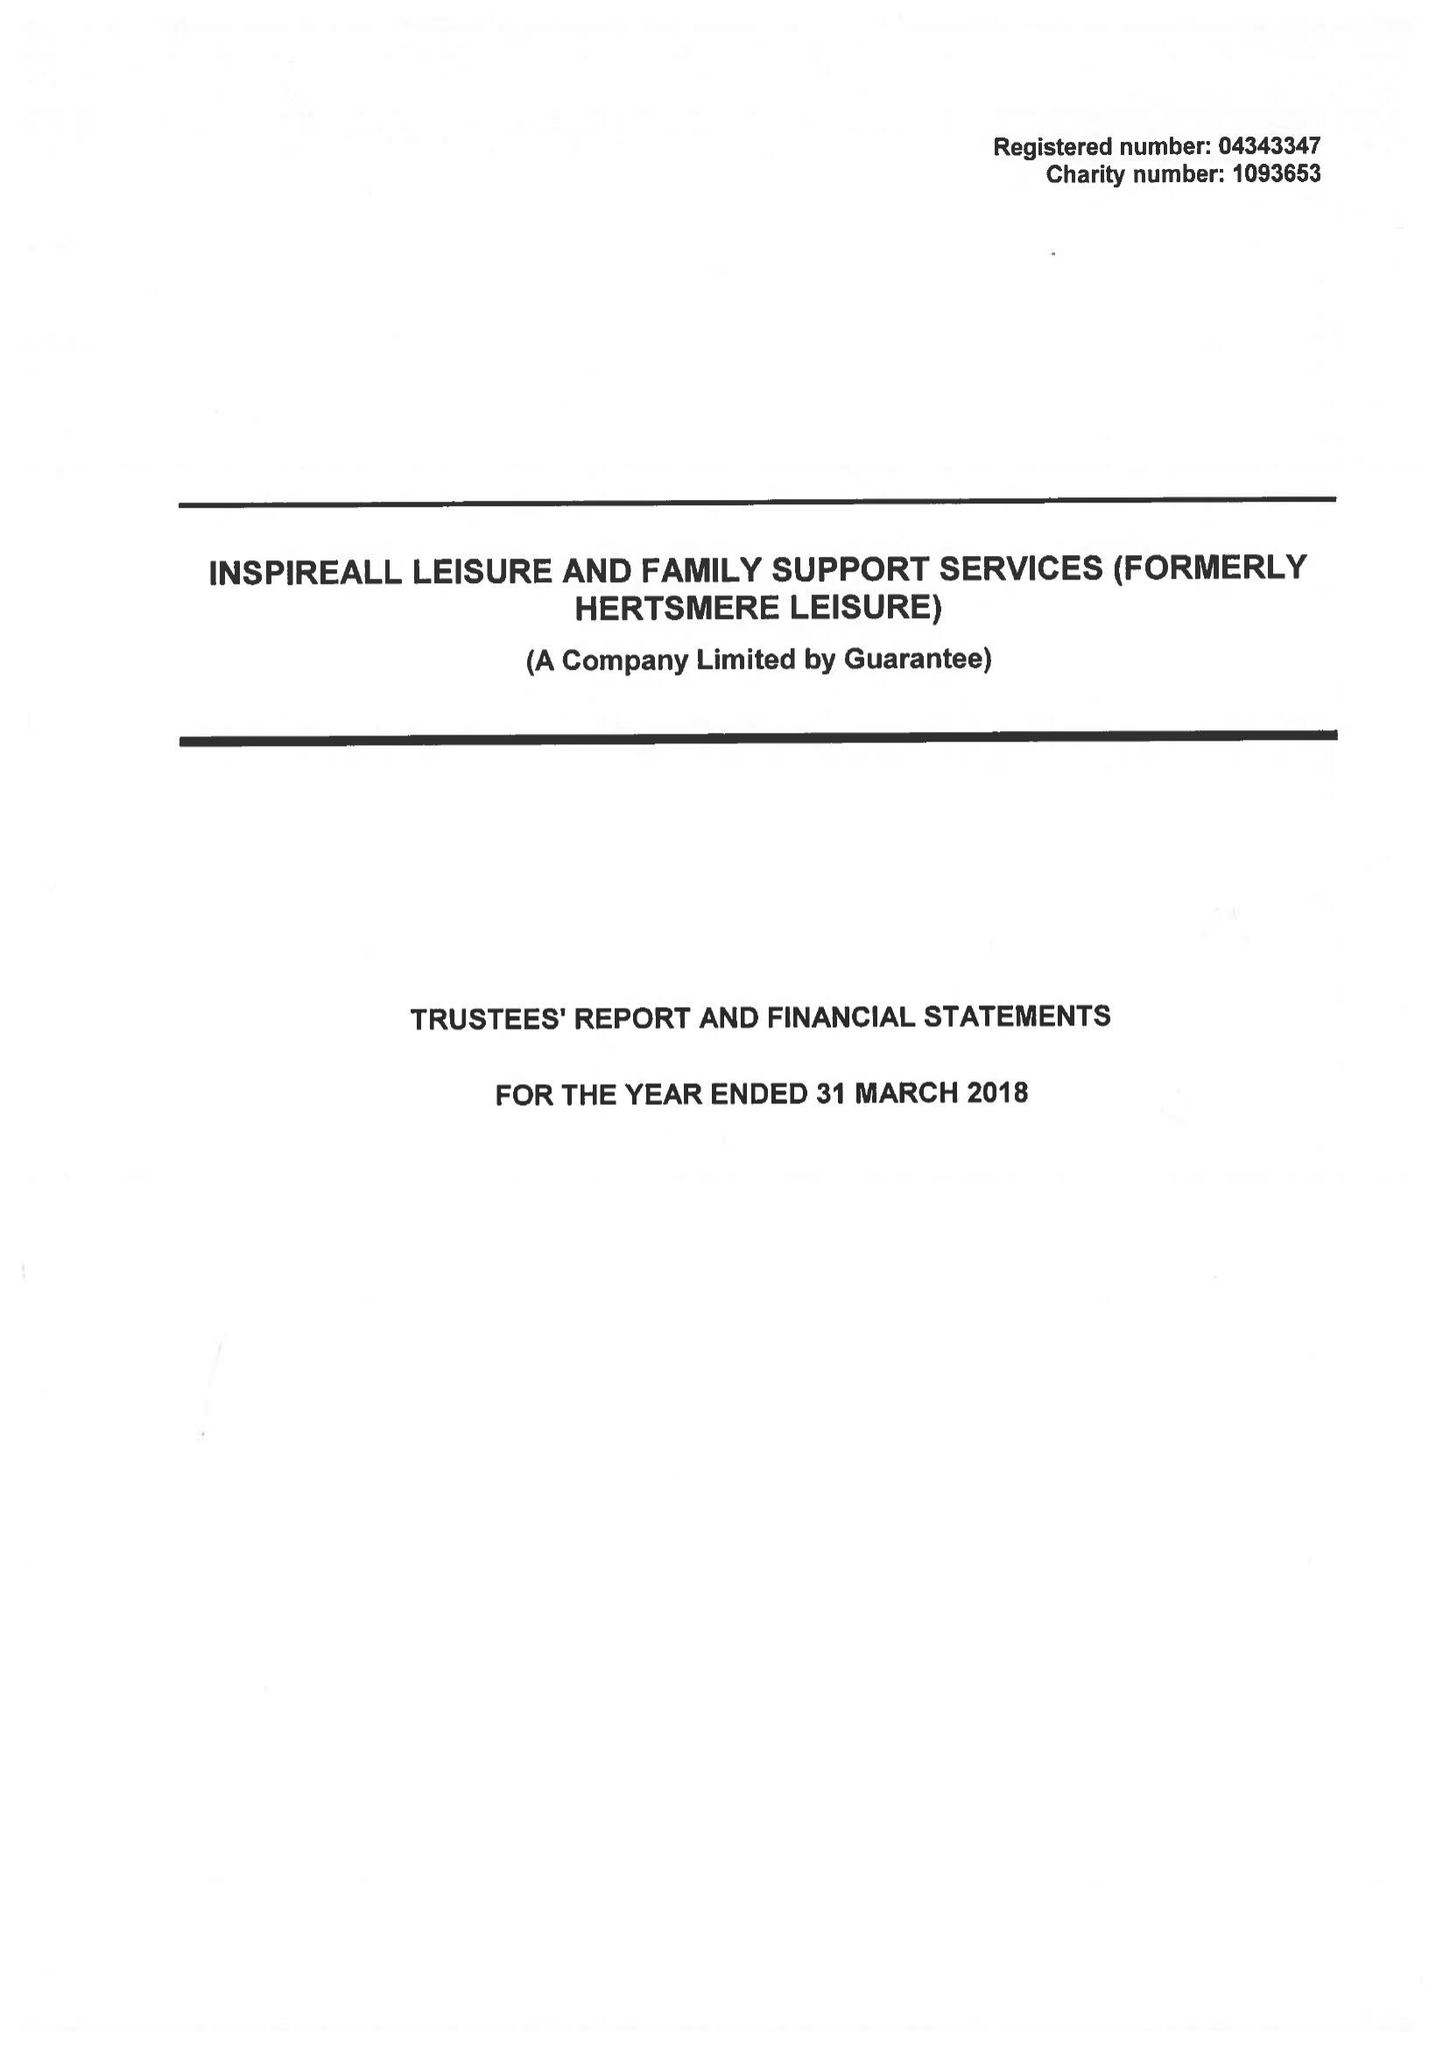What is the value for the address__postcode?
Answer the question using a single word or phrase. WD6 1JY 